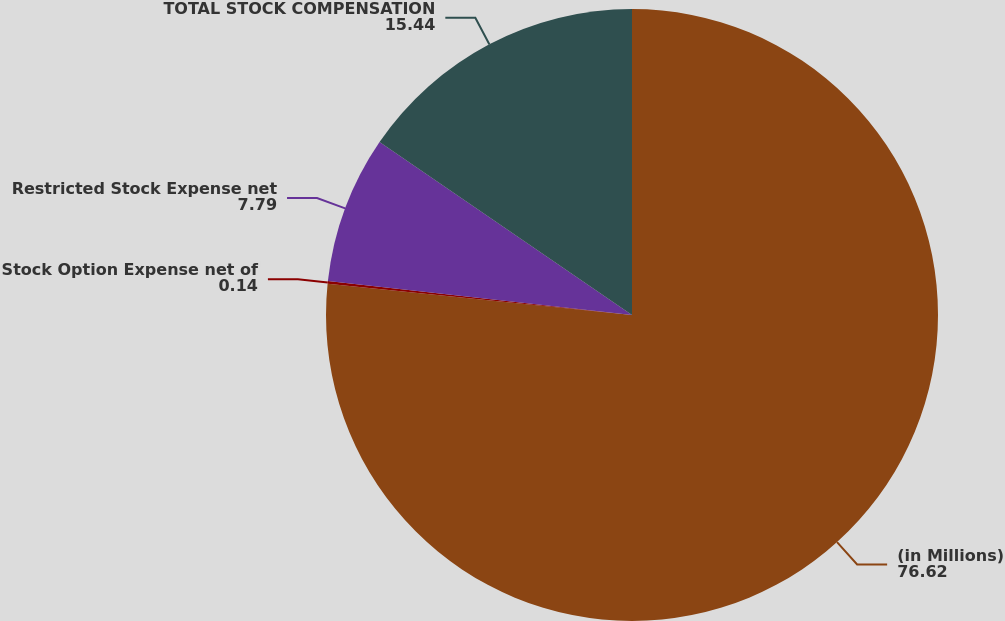Convert chart. <chart><loc_0><loc_0><loc_500><loc_500><pie_chart><fcel>(in Millions)<fcel>Stock Option Expense net of<fcel>Restricted Stock Expense net<fcel>TOTAL STOCK COMPENSATION<nl><fcel>76.62%<fcel>0.14%<fcel>7.79%<fcel>15.44%<nl></chart> 